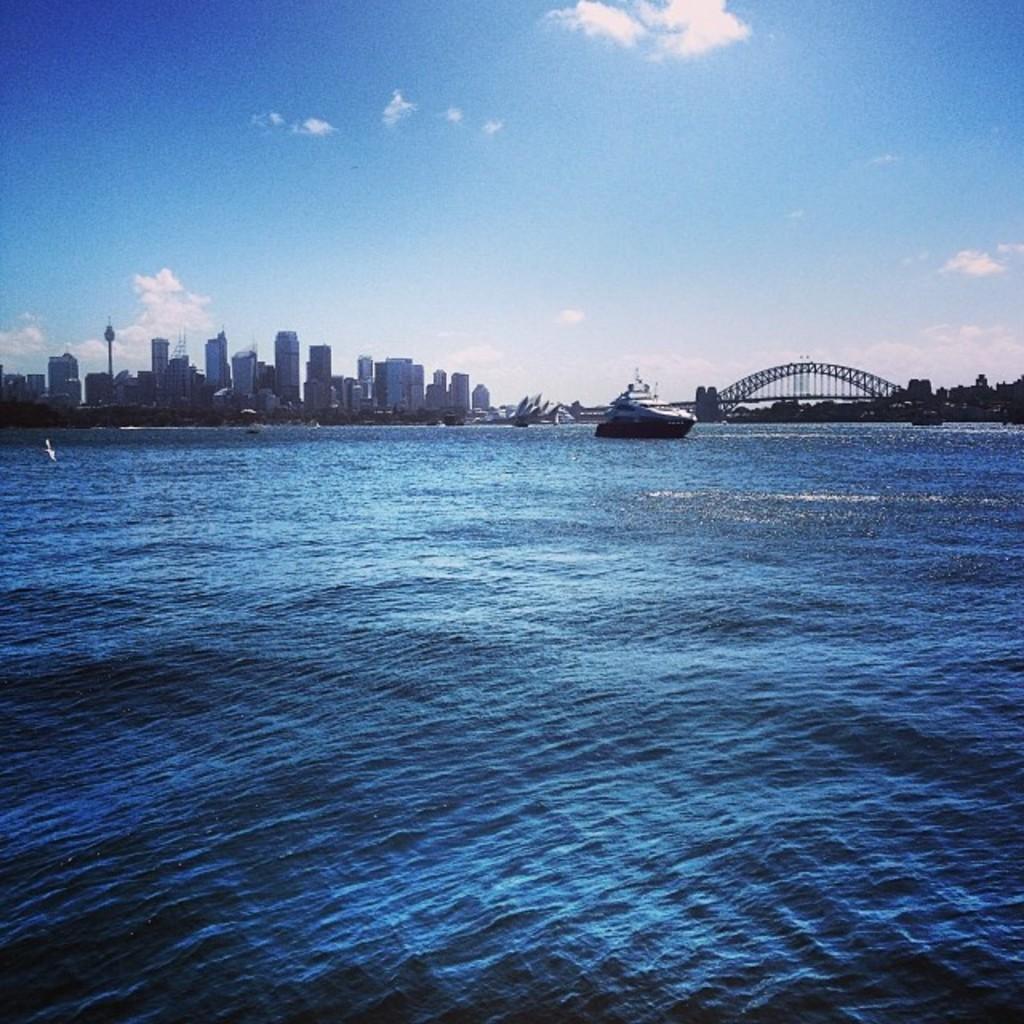Please provide a concise description of this image. In this image I can see a ship in the water, beside that there is a bridge, trees and a skyline view of buildings. 